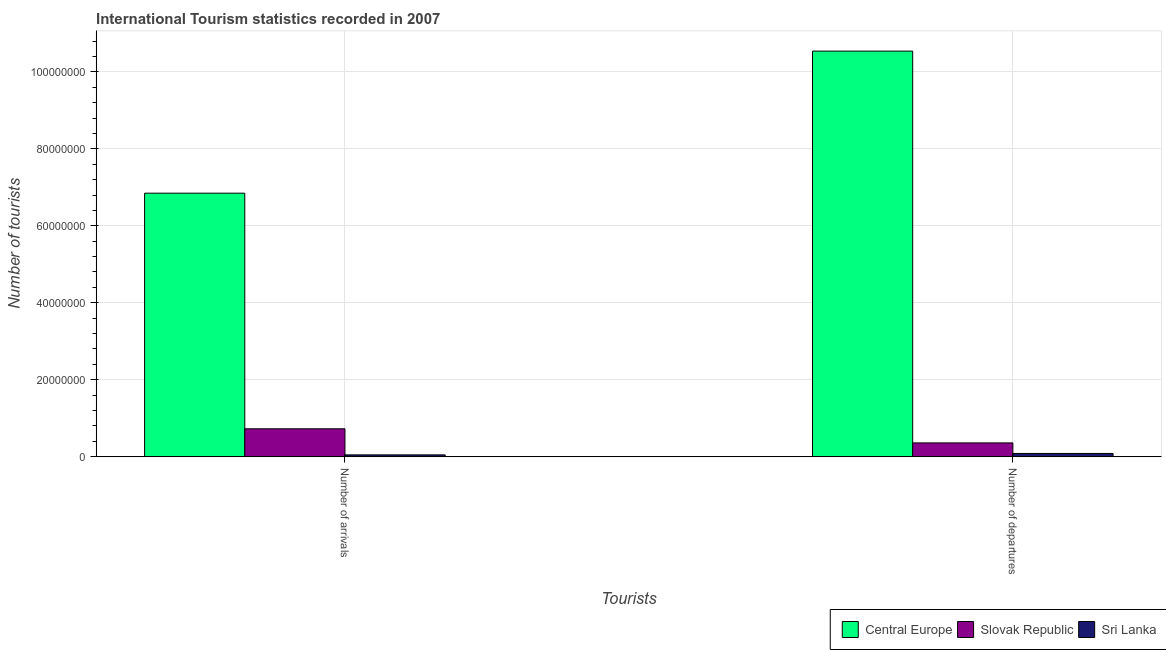How many different coloured bars are there?
Offer a terse response. 3. How many groups of bars are there?
Your answer should be very brief. 2. Are the number of bars per tick equal to the number of legend labels?
Give a very brief answer. Yes. Are the number of bars on each tick of the X-axis equal?
Keep it short and to the point. Yes. What is the label of the 1st group of bars from the left?
Make the answer very short. Number of arrivals. What is the number of tourist departures in Sri Lanka?
Ensure brevity in your answer.  8.62e+05. Across all countries, what is the maximum number of tourist departures?
Ensure brevity in your answer.  1.05e+08. Across all countries, what is the minimum number of tourist arrivals?
Your answer should be compact. 4.94e+05. In which country was the number of tourist departures maximum?
Provide a succinct answer. Central Europe. In which country was the number of tourist arrivals minimum?
Your answer should be compact. Sri Lanka. What is the total number of tourist arrivals in the graph?
Offer a very short reply. 7.62e+07. What is the difference between the number of tourist departures in Sri Lanka and that in Slovak Republic?
Give a very brief answer. -2.74e+06. What is the difference between the number of tourist departures in Central Europe and the number of tourist arrivals in Slovak Republic?
Make the answer very short. 9.81e+07. What is the average number of tourist departures per country?
Your response must be concise. 3.66e+07. What is the difference between the number of tourist departures and number of tourist arrivals in Slovak Republic?
Make the answer very short. -3.67e+06. In how many countries, is the number of tourist arrivals greater than 32000000 ?
Offer a very short reply. 1. What is the ratio of the number of tourist arrivals in Slovak Republic to that in Central Europe?
Provide a succinct answer. 0.11. Is the number of tourist arrivals in Slovak Republic less than that in Sri Lanka?
Keep it short and to the point. No. In how many countries, is the number of tourist arrivals greater than the average number of tourist arrivals taken over all countries?
Give a very brief answer. 1. What does the 1st bar from the left in Number of departures represents?
Offer a terse response. Central Europe. What does the 1st bar from the right in Number of departures represents?
Offer a very short reply. Sri Lanka. How many countries are there in the graph?
Your answer should be very brief. 3. What is the difference between two consecutive major ticks on the Y-axis?
Your answer should be compact. 2.00e+07. Does the graph contain any zero values?
Keep it short and to the point. No. How many legend labels are there?
Make the answer very short. 3. How are the legend labels stacked?
Give a very brief answer. Horizontal. What is the title of the graph?
Your answer should be compact. International Tourism statistics recorded in 2007. What is the label or title of the X-axis?
Make the answer very short. Tourists. What is the label or title of the Y-axis?
Offer a terse response. Number of tourists. What is the Number of tourists of Central Europe in Number of arrivals?
Ensure brevity in your answer.  6.85e+07. What is the Number of tourists of Slovak Republic in Number of arrivals?
Your response must be concise. 7.27e+06. What is the Number of tourists of Sri Lanka in Number of arrivals?
Give a very brief answer. 4.94e+05. What is the Number of tourists of Central Europe in Number of departures?
Ensure brevity in your answer.  1.05e+08. What is the Number of tourists of Slovak Republic in Number of departures?
Provide a short and direct response. 3.60e+06. What is the Number of tourists of Sri Lanka in Number of departures?
Offer a very short reply. 8.62e+05. Across all Tourists, what is the maximum Number of tourists of Central Europe?
Give a very brief answer. 1.05e+08. Across all Tourists, what is the maximum Number of tourists in Slovak Republic?
Give a very brief answer. 7.27e+06. Across all Tourists, what is the maximum Number of tourists in Sri Lanka?
Offer a terse response. 8.62e+05. Across all Tourists, what is the minimum Number of tourists in Central Europe?
Make the answer very short. 6.85e+07. Across all Tourists, what is the minimum Number of tourists in Slovak Republic?
Offer a terse response. 3.60e+06. Across all Tourists, what is the minimum Number of tourists in Sri Lanka?
Your answer should be compact. 4.94e+05. What is the total Number of tourists of Central Europe in the graph?
Offer a very short reply. 1.74e+08. What is the total Number of tourists of Slovak Republic in the graph?
Offer a very short reply. 1.09e+07. What is the total Number of tourists in Sri Lanka in the graph?
Keep it short and to the point. 1.36e+06. What is the difference between the Number of tourists in Central Europe in Number of arrivals and that in Number of departures?
Offer a terse response. -3.69e+07. What is the difference between the Number of tourists of Slovak Republic in Number of arrivals and that in Number of departures?
Keep it short and to the point. 3.67e+06. What is the difference between the Number of tourists of Sri Lanka in Number of arrivals and that in Number of departures?
Give a very brief answer. -3.68e+05. What is the difference between the Number of tourists of Central Europe in Number of arrivals and the Number of tourists of Slovak Republic in Number of departures?
Provide a short and direct response. 6.49e+07. What is the difference between the Number of tourists in Central Europe in Number of arrivals and the Number of tourists in Sri Lanka in Number of departures?
Keep it short and to the point. 6.76e+07. What is the difference between the Number of tourists in Slovak Republic in Number of arrivals and the Number of tourists in Sri Lanka in Number of departures?
Ensure brevity in your answer.  6.41e+06. What is the average Number of tourists of Central Europe per Tourists?
Make the answer very short. 8.69e+07. What is the average Number of tourists of Slovak Republic per Tourists?
Your response must be concise. 5.44e+06. What is the average Number of tourists in Sri Lanka per Tourists?
Provide a succinct answer. 6.78e+05. What is the difference between the Number of tourists in Central Europe and Number of tourists in Slovak Republic in Number of arrivals?
Give a very brief answer. 6.12e+07. What is the difference between the Number of tourists in Central Europe and Number of tourists in Sri Lanka in Number of arrivals?
Provide a short and direct response. 6.80e+07. What is the difference between the Number of tourists of Slovak Republic and Number of tourists of Sri Lanka in Number of arrivals?
Provide a short and direct response. 6.78e+06. What is the difference between the Number of tourists in Central Europe and Number of tourists in Slovak Republic in Number of departures?
Provide a succinct answer. 1.02e+08. What is the difference between the Number of tourists of Central Europe and Number of tourists of Sri Lanka in Number of departures?
Offer a very short reply. 1.05e+08. What is the difference between the Number of tourists in Slovak Republic and Number of tourists in Sri Lanka in Number of departures?
Give a very brief answer. 2.74e+06. What is the ratio of the Number of tourists in Central Europe in Number of arrivals to that in Number of departures?
Offer a terse response. 0.65. What is the ratio of the Number of tourists of Slovak Republic in Number of arrivals to that in Number of departures?
Make the answer very short. 2.02. What is the ratio of the Number of tourists in Sri Lanka in Number of arrivals to that in Number of departures?
Provide a succinct answer. 0.57. What is the difference between the highest and the second highest Number of tourists in Central Europe?
Your answer should be very brief. 3.69e+07. What is the difference between the highest and the second highest Number of tourists of Slovak Republic?
Provide a short and direct response. 3.67e+06. What is the difference between the highest and the second highest Number of tourists of Sri Lanka?
Offer a very short reply. 3.68e+05. What is the difference between the highest and the lowest Number of tourists of Central Europe?
Your answer should be very brief. 3.69e+07. What is the difference between the highest and the lowest Number of tourists in Slovak Republic?
Make the answer very short. 3.67e+06. What is the difference between the highest and the lowest Number of tourists in Sri Lanka?
Make the answer very short. 3.68e+05. 